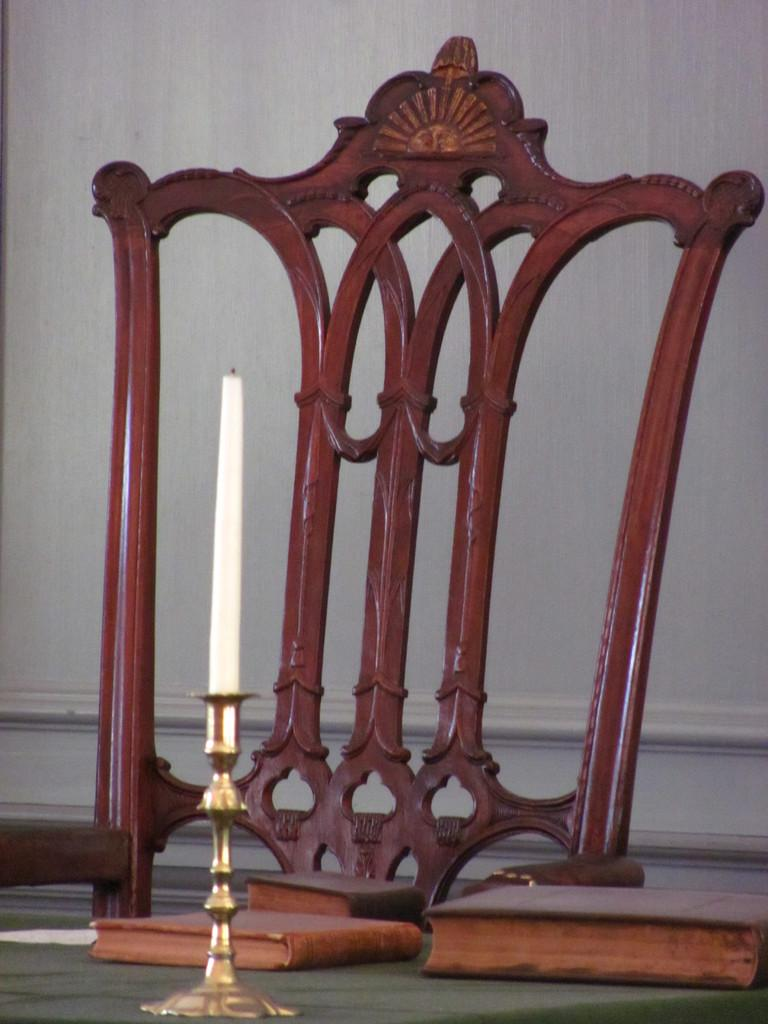What type of furniture is present in the image? There is a chair and a table in the image. What objects can be seen on the table? There are books and a candle stand on the table. What is on the candle stand? There is a candle on the candle stand. What can be seen in the background of the image? There is a wall in the background of the image. Is there a volcano erupting in the image? No, there is no volcano present in the image. What type of wheel is visible in the image? There is no wheel present in the image. 